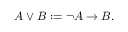Convert formula to latex. <formula><loc_0><loc_0><loc_500><loc_500>\ A \vee B \colon = \neg A \rightarrow B .</formula> 